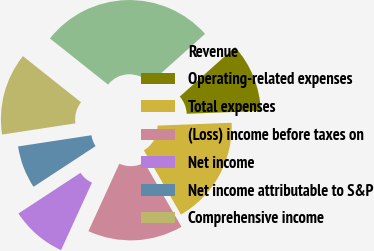Convert chart. <chart><loc_0><loc_0><loc_500><loc_500><pie_chart><fcel>Revenue<fcel>Operating-related expenses<fcel>Total expenses<fcel>(Loss) income before taxes on<fcel>Net income<fcel>Net income attributable to S&P<fcel>Comprehensive income<nl><fcel>27.7%<fcel>11.01%<fcel>17.27%<fcel>15.18%<fcel>8.92%<fcel>6.83%<fcel>13.09%<nl></chart> 